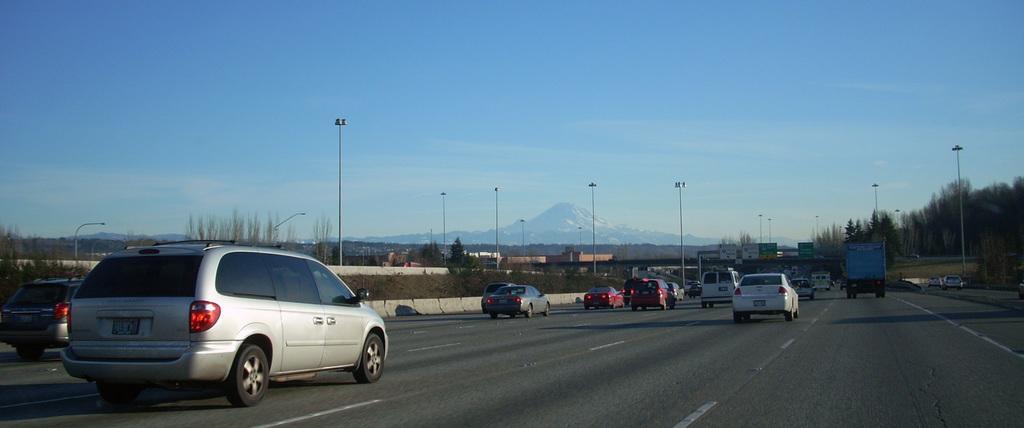Describe this image in one or two sentences. In this image we can see a few vehicles on the road, there are some poles, lights, trees, mountains, buildings and boards with some text, in the background we can see the sky with clouds. 